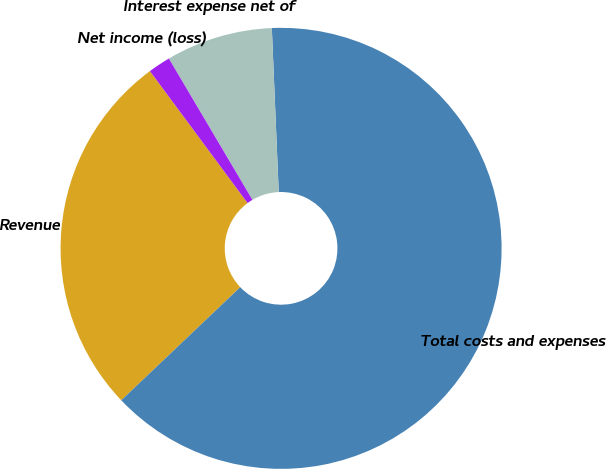Convert chart to OTSL. <chart><loc_0><loc_0><loc_500><loc_500><pie_chart><fcel>Revenue<fcel>Total costs and expenses<fcel>Interest expense net of<fcel>Net income (loss)<nl><fcel>26.96%<fcel>63.57%<fcel>7.83%<fcel>1.64%<nl></chart> 